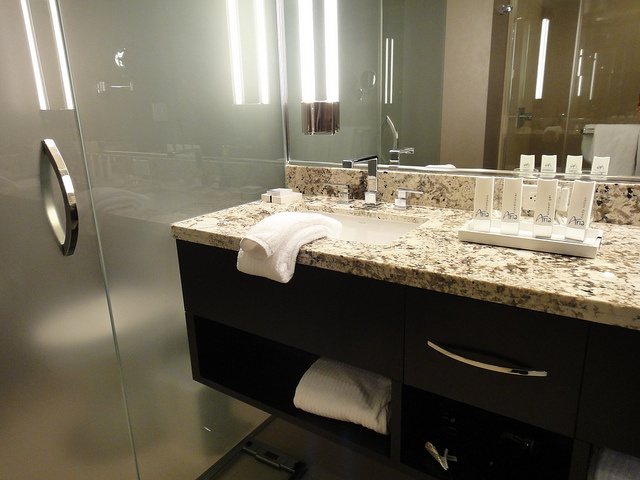Describe the objects in this image and their specific colors. I can see a sink in tan and beige tones in this image. 